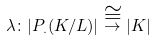<formula> <loc_0><loc_0><loc_500><loc_500>\lambda \colon | P _ { . } ( K / L ) | \stackrel { \cong } \to { | K | }</formula> 